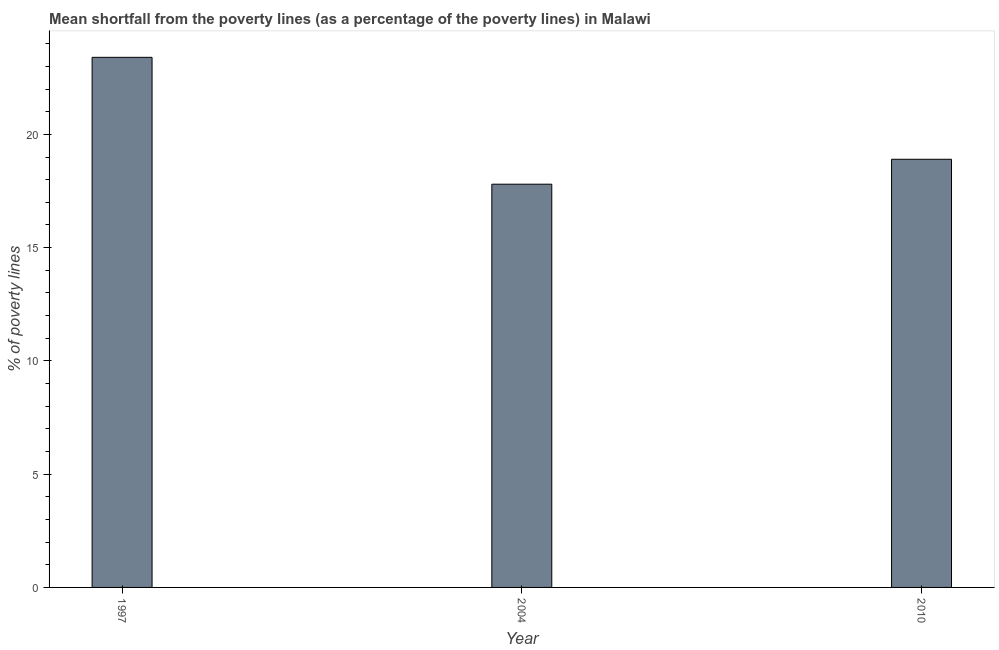Does the graph contain any zero values?
Give a very brief answer. No. Does the graph contain grids?
Make the answer very short. No. What is the title of the graph?
Provide a short and direct response. Mean shortfall from the poverty lines (as a percentage of the poverty lines) in Malawi. What is the label or title of the X-axis?
Provide a succinct answer. Year. What is the label or title of the Y-axis?
Keep it short and to the point. % of poverty lines. What is the poverty gap at national poverty lines in 1997?
Offer a very short reply. 23.4. Across all years, what is the maximum poverty gap at national poverty lines?
Offer a terse response. 23.4. In which year was the poverty gap at national poverty lines maximum?
Your answer should be very brief. 1997. What is the sum of the poverty gap at national poverty lines?
Give a very brief answer. 60.1. What is the difference between the poverty gap at national poverty lines in 1997 and 2004?
Provide a short and direct response. 5.6. What is the average poverty gap at national poverty lines per year?
Your response must be concise. 20.03. What is the ratio of the poverty gap at national poverty lines in 1997 to that in 2010?
Ensure brevity in your answer.  1.24. Is the poverty gap at national poverty lines in 1997 less than that in 2010?
Offer a very short reply. No. What is the difference between the highest and the second highest poverty gap at national poverty lines?
Provide a short and direct response. 4.5. What is the difference between the highest and the lowest poverty gap at national poverty lines?
Keep it short and to the point. 5.6. In how many years, is the poverty gap at national poverty lines greater than the average poverty gap at national poverty lines taken over all years?
Ensure brevity in your answer.  1. Are all the bars in the graph horizontal?
Offer a very short reply. No. Are the values on the major ticks of Y-axis written in scientific E-notation?
Offer a very short reply. No. What is the % of poverty lines of 1997?
Make the answer very short. 23.4. What is the % of poverty lines of 2004?
Make the answer very short. 17.8. What is the % of poverty lines in 2010?
Ensure brevity in your answer.  18.9. What is the difference between the % of poverty lines in 1997 and 2004?
Provide a short and direct response. 5.6. What is the difference between the % of poverty lines in 1997 and 2010?
Provide a succinct answer. 4.5. What is the ratio of the % of poverty lines in 1997 to that in 2004?
Your answer should be very brief. 1.31. What is the ratio of the % of poverty lines in 1997 to that in 2010?
Give a very brief answer. 1.24. What is the ratio of the % of poverty lines in 2004 to that in 2010?
Make the answer very short. 0.94. 